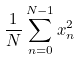<formula> <loc_0><loc_0><loc_500><loc_500>\frac { 1 } { N } \sum _ { n = 0 } ^ { N - 1 } x _ { n } ^ { 2 }</formula> 